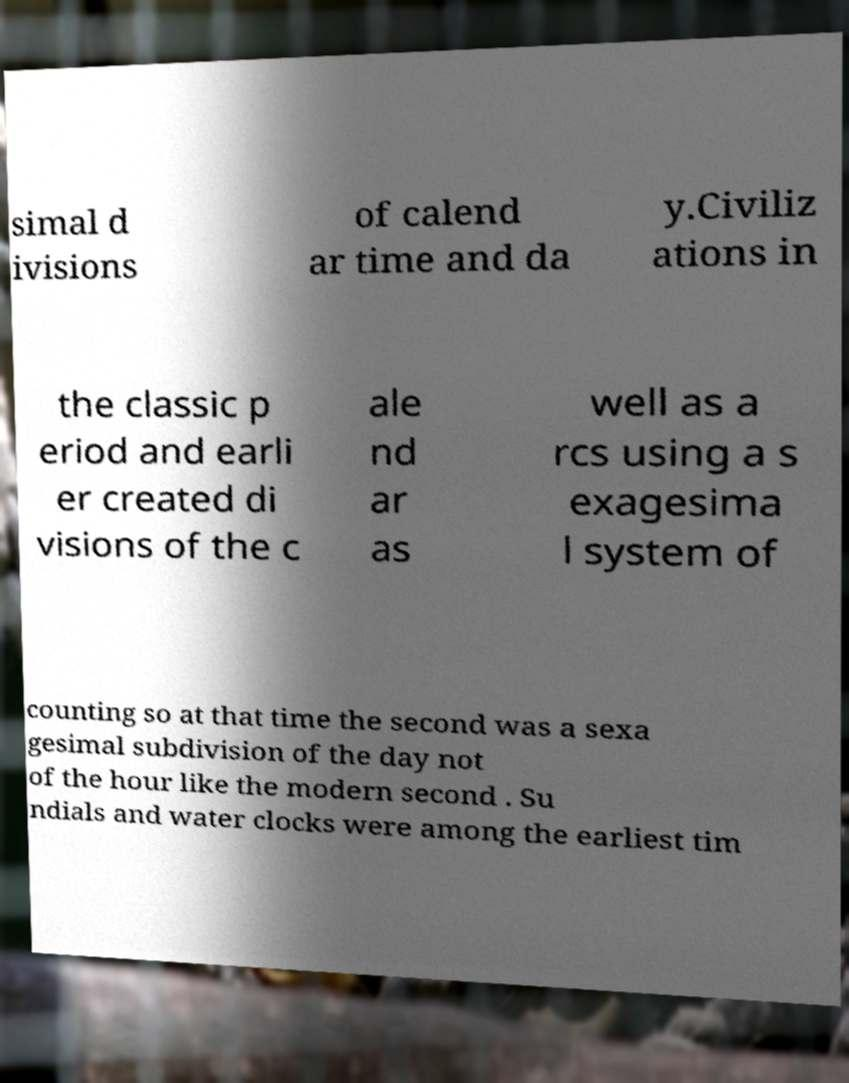Please identify and transcribe the text found in this image. simal d ivisions of calend ar time and da y.Civiliz ations in the classic p eriod and earli er created di visions of the c ale nd ar as well as a rcs using a s exagesima l system of counting so at that time the second was a sexa gesimal subdivision of the day not of the hour like the modern second . Su ndials and water clocks were among the earliest tim 